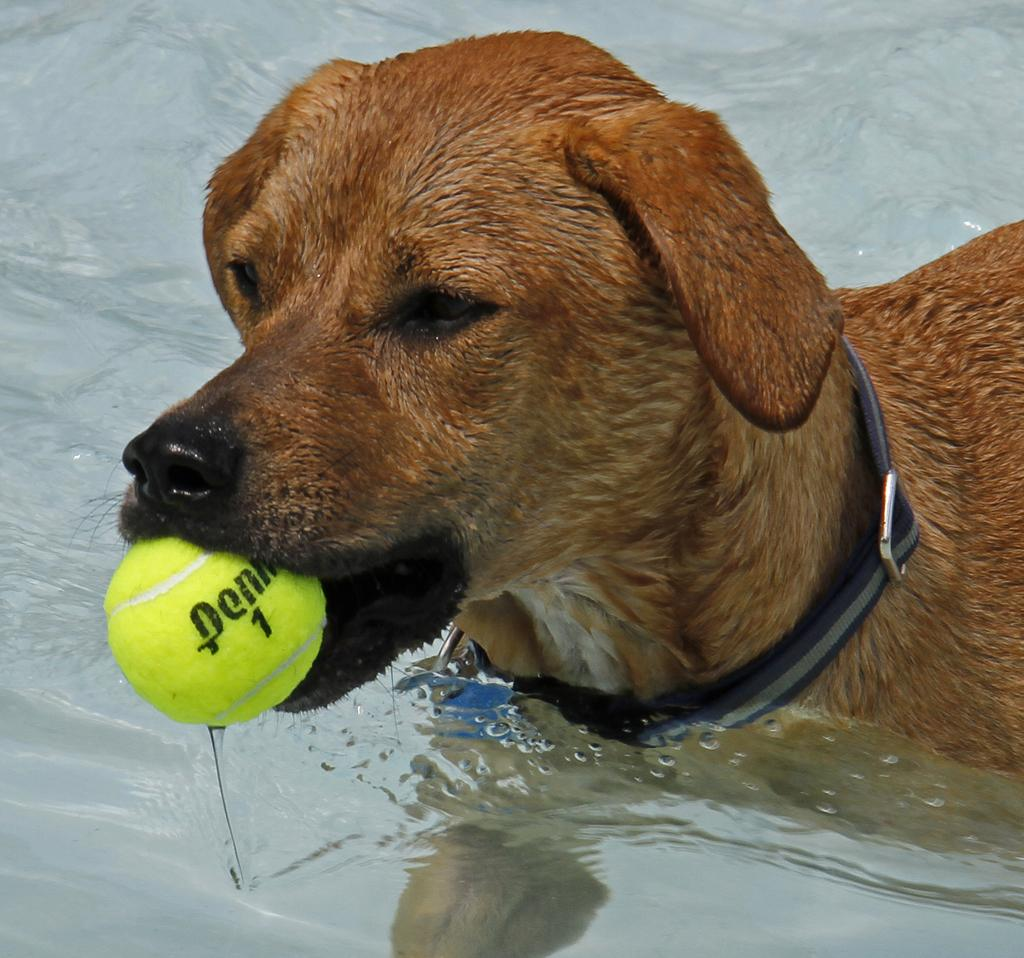What animal is present in the image? There is a dog in the image. What object is the dog holding in the image? The dog is holding a ball. Where is the dog located in the image? The dog is in water. What type of jewel is the dog wearing around its neck in the image? There is no jewel visible around the dog's neck in the image. What is the dog's reaction to the poison in the water in the image? There is no mention of poison in the water or any reaction from the dog in the image. 